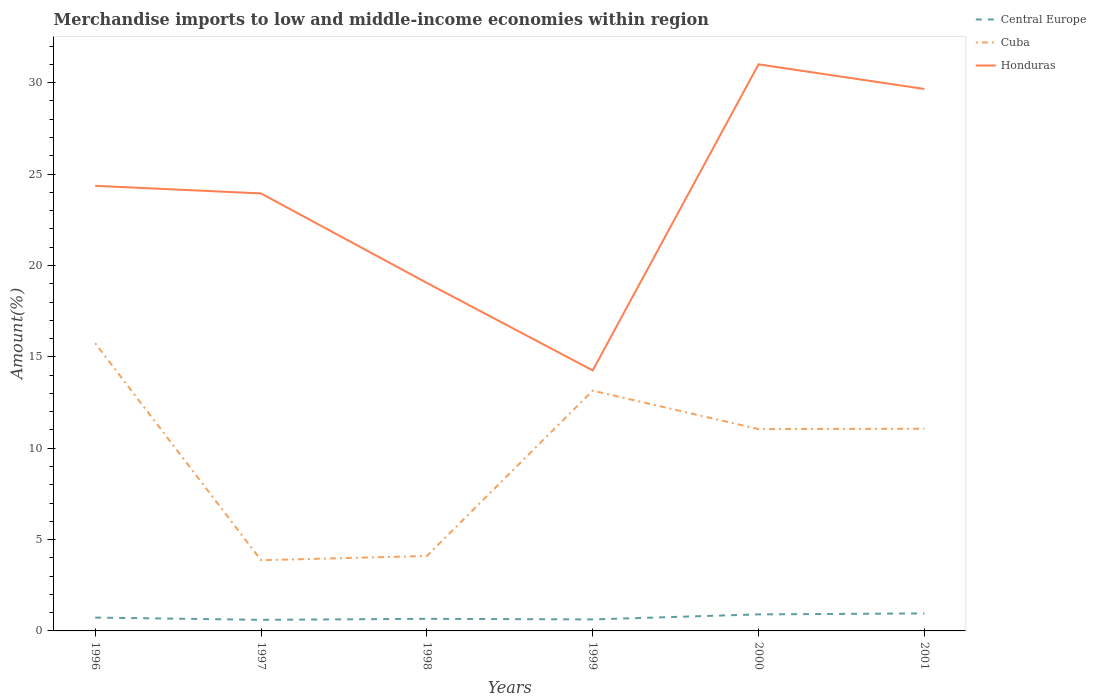How many different coloured lines are there?
Offer a terse response. 3. Across all years, what is the maximum percentage of amount earned from merchandise imports in Honduras?
Offer a very short reply. 14.26. In which year was the percentage of amount earned from merchandise imports in Honduras maximum?
Your response must be concise. 1999. What is the total percentage of amount earned from merchandise imports in Honduras in the graph?
Your answer should be compact. -5.3. What is the difference between the highest and the second highest percentage of amount earned from merchandise imports in Honduras?
Make the answer very short. 16.75. What is the difference between the highest and the lowest percentage of amount earned from merchandise imports in Central Europe?
Offer a very short reply. 2. Is the percentage of amount earned from merchandise imports in Cuba strictly greater than the percentage of amount earned from merchandise imports in Honduras over the years?
Keep it short and to the point. Yes. How many years are there in the graph?
Keep it short and to the point. 6. What is the difference between two consecutive major ticks on the Y-axis?
Your response must be concise. 5. Does the graph contain grids?
Make the answer very short. No. How are the legend labels stacked?
Offer a very short reply. Vertical. What is the title of the graph?
Offer a terse response. Merchandise imports to low and middle-income economies within region. Does "Namibia" appear as one of the legend labels in the graph?
Make the answer very short. No. What is the label or title of the X-axis?
Provide a short and direct response. Years. What is the label or title of the Y-axis?
Give a very brief answer. Amount(%). What is the Amount(%) in Central Europe in 1996?
Your answer should be very brief. 0.73. What is the Amount(%) of Cuba in 1996?
Give a very brief answer. 15.75. What is the Amount(%) in Honduras in 1996?
Provide a succinct answer. 24.36. What is the Amount(%) in Central Europe in 1997?
Make the answer very short. 0.61. What is the Amount(%) in Cuba in 1997?
Make the answer very short. 3.87. What is the Amount(%) of Honduras in 1997?
Provide a short and direct response. 23.94. What is the Amount(%) of Central Europe in 1998?
Offer a terse response. 0.66. What is the Amount(%) of Cuba in 1998?
Provide a short and direct response. 4.1. What is the Amount(%) in Honduras in 1998?
Provide a succinct answer. 19.05. What is the Amount(%) in Central Europe in 1999?
Your response must be concise. 0.63. What is the Amount(%) in Cuba in 1999?
Offer a terse response. 13.15. What is the Amount(%) in Honduras in 1999?
Provide a succinct answer. 14.26. What is the Amount(%) in Central Europe in 2000?
Your response must be concise. 0.91. What is the Amount(%) in Cuba in 2000?
Offer a terse response. 11.05. What is the Amount(%) in Honduras in 2000?
Keep it short and to the point. 31.01. What is the Amount(%) of Central Europe in 2001?
Make the answer very short. 0.96. What is the Amount(%) in Cuba in 2001?
Ensure brevity in your answer.  11.07. What is the Amount(%) in Honduras in 2001?
Offer a terse response. 29.66. Across all years, what is the maximum Amount(%) in Central Europe?
Provide a succinct answer. 0.96. Across all years, what is the maximum Amount(%) in Cuba?
Offer a very short reply. 15.75. Across all years, what is the maximum Amount(%) in Honduras?
Offer a terse response. 31.01. Across all years, what is the minimum Amount(%) in Central Europe?
Ensure brevity in your answer.  0.61. Across all years, what is the minimum Amount(%) of Cuba?
Your answer should be compact. 3.87. Across all years, what is the minimum Amount(%) of Honduras?
Keep it short and to the point. 14.26. What is the total Amount(%) in Central Europe in the graph?
Offer a terse response. 4.49. What is the total Amount(%) of Cuba in the graph?
Make the answer very short. 58.98. What is the total Amount(%) in Honduras in the graph?
Your response must be concise. 142.26. What is the difference between the Amount(%) in Central Europe in 1996 and that in 1997?
Give a very brief answer. 0.12. What is the difference between the Amount(%) in Cuba in 1996 and that in 1997?
Your answer should be compact. 11.88. What is the difference between the Amount(%) of Honduras in 1996 and that in 1997?
Provide a short and direct response. 0.42. What is the difference between the Amount(%) of Central Europe in 1996 and that in 1998?
Provide a succinct answer. 0.07. What is the difference between the Amount(%) of Cuba in 1996 and that in 1998?
Your answer should be compact. 11.65. What is the difference between the Amount(%) in Honduras in 1996 and that in 1998?
Your answer should be very brief. 5.31. What is the difference between the Amount(%) in Central Europe in 1996 and that in 1999?
Your response must be concise. 0.1. What is the difference between the Amount(%) of Cuba in 1996 and that in 1999?
Your answer should be compact. 2.6. What is the difference between the Amount(%) of Honduras in 1996 and that in 1999?
Your response must be concise. 10.1. What is the difference between the Amount(%) of Central Europe in 1996 and that in 2000?
Your answer should be compact. -0.17. What is the difference between the Amount(%) in Cuba in 1996 and that in 2000?
Your answer should be very brief. 4.7. What is the difference between the Amount(%) of Honduras in 1996 and that in 2000?
Offer a very short reply. -6.65. What is the difference between the Amount(%) of Central Europe in 1996 and that in 2001?
Offer a terse response. -0.23. What is the difference between the Amount(%) of Cuba in 1996 and that in 2001?
Give a very brief answer. 4.68. What is the difference between the Amount(%) of Honduras in 1996 and that in 2001?
Provide a short and direct response. -5.3. What is the difference between the Amount(%) of Central Europe in 1997 and that in 1998?
Offer a terse response. -0.05. What is the difference between the Amount(%) of Cuba in 1997 and that in 1998?
Offer a very short reply. -0.23. What is the difference between the Amount(%) in Honduras in 1997 and that in 1998?
Offer a terse response. 4.9. What is the difference between the Amount(%) in Central Europe in 1997 and that in 1999?
Your answer should be very brief. -0.02. What is the difference between the Amount(%) in Cuba in 1997 and that in 1999?
Your answer should be very brief. -9.28. What is the difference between the Amount(%) of Honduras in 1997 and that in 1999?
Your answer should be compact. 9.69. What is the difference between the Amount(%) in Central Europe in 1997 and that in 2000?
Ensure brevity in your answer.  -0.3. What is the difference between the Amount(%) in Cuba in 1997 and that in 2000?
Keep it short and to the point. -7.18. What is the difference between the Amount(%) of Honduras in 1997 and that in 2000?
Your answer should be compact. -7.06. What is the difference between the Amount(%) of Central Europe in 1997 and that in 2001?
Your answer should be very brief. -0.35. What is the difference between the Amount(%) of Cuba in 1997 and that in 2001?
Ensure brevity in your answer.  -7.2. What is the difference between the Amount(%) of Honduras in 1997 and that in 2001?
Offer a very short reply. -5.72. What is the difference between the Amount(%) in Central Europe in 1998 and that in 1999?
Your answer should be very brief. 0.03. What is the difference between the Amount(%) of Cuba in 1998 and that in 1999?
Make the answer very short. -9.05. What is the difference between the Amount(%) of Honduras in 1998 and that in 1999?
Offer a terse response. 4.79. What is the difference between the Amount(%) in Central Europe in 1998 and that in 2000?
Make the answer very short. -0.24. What is the difference between the Amount(%) in Cuba in 1998 and that in 2000?
Offer a very short reply. -6.94. What is the difference between the Amount(%) in Honduras in 1998 and that in 2000?
Provide a short and direct response. -11.96. What is the difference between the Amount(%) of Central Europe in 1998 and that in 2001?
Keep it short and to the point. -0.3. What is the difference between the Amount(%) of Cuba in 1998 and that in 2001?
Ensure brevity in your answer.  -6.97. What is the difference between the Amount(%) in Honduras in 1998 and that in 2001?
Provide a succinct answer. -10.61. What is the difference between the Amount(%) of Central Europe in 1999 and that in 2000?
Your response must be concise. -0.28. What is the difference between the Amount(%) of Cuba in 1999 and that in 2000?
Make the answer very short. 2.1. What is the difference between the Amount(%) in Honduras in 1999 and that in 2000?
Ensure brevity in your answer.  -16.75. What is the difference between the Amount(%) in Central Europe in 1999 and that in 2001?
Make the answer very short. -0.33. What is the difference between the Amount(%) in Cuba in 1999 and that in 2001?
Offer a terse response. 2.08. What is the difference between the Amount(%) in Honduras in 1999 and that in 2001?
Provide a succinct answer. -15.4. What is the difference between the Amount(%) of Central Europe in 2000 and that in 2001?
Your answer should be compact. -0.05. What is the difference between the Amount(%) of Cuba in 2000 and that in 2001?
Keep it short and to the point. -0.02. What is the difference between the Amount(%) in Honduras in 2000 and that in 2001?
Offer a very short reply. 1.35. What is the difference between the Amount(%) in Central Europe in 1996 and the Amount(%) in Cuba in 1997?
Provide a short and direct response. -3.14. What is the difference between the Amount(%) of Central Europe in 1996 and the Amount(%) of Honduras in 1997?
Provide a short and direct response. -23.21. What is the difference between the Amount(%) of Cuba in 1996 and the Amount(%) of Honduras in 1997?
Offer a very short reply. -8.19. What is the difference between the Amount(%) of Central Europe in 1996 and the Amount(%) of Cuba in 1998?
Offer a very short reply. -3.37. What is the difference between the Amount(%) of Central Europe in 1996 and the Amount(%) of Honduras in 1998?
Your answer should be compact. -18.32. What is the difference between the Amount(%) in Cuba in 1996 and the Amount(%) in Honduras in 1998?
Offer a terse response. -3.3. What is the difference between the Amount(%) in Central Europe in 1996 and the Amount(%) in Cuba in 1999?
Provide a succinct answer. -12.42. What is the difference between the Amount(%) in Central Europe in 1996 and the Amount(%) in Honduras in 1999?
Make the answer very short. -13.53. What is the difference between the Amount(%) of Cuba in 1996 and the Amount(%) of Honduras in 1999?
Provide a short and direct response. 1.49. What is the difference between the Amount(%) of Central Europe in 1996 and the Amount(%) of Cuba in 2000?
Keep it short and to the point. -10.31. What is the difference between the Amount(%) in Central Europe in 1996 and the Amount(%) in Honduras in 2000?
Your answer should be compact. -30.28. What is the difference between the Amount(%) of Cuba in 1996 and the Amount(%) of Honduras in 2000?
Your answer should be compact. -15.26. What is the difference between the Amount(%) in Central Europe in 1996 and the Amount(%) in Cuba in 2001?
Your answer should be very brief. -10.34. What is the difference between the Amount(%) in Central Europe in 1996 and the Amount(%) in Honduras in 2001?
Provide a short and direct response. -28.93. What is the difference between the Amount(%) in Cuba in 1996 and the Amount(%) in Honduras in 2001?
Give a very brief answer. -13.91. What is the difference between the Amount(%) of Central Europe in 1997 and the Amount(%) of Cuba in 1998?
Provide a succinct answer. -3.49. What is the difference between the Amount(%) in Central Europe in 1997 and the Amount(%) in Honduras in 1998?
Provide a short and direct response. -18.44. What is the difference between the Amount(%) of Cuba in 1997 and the Amount(%) of Honduras in 1998?
Offer a very short reply. -15.18. What is the difference between the Amount(%) in Central Europe in 1997 and the Amount(%) in Cuba in 1999?
Keep it short and to the point. -12.54. What is the difference between the Amount(%) in Central Europe in 1997 and the Amount(%) in Honduras in 1999?
Keep it short and to the point. -13.65. What is the difference between the Amount(%) of Cuba in 1997 and the Amount(%) of Honduras in 1999?
Give a very brief answer. -10.39. What is the difference between the Amount(%) in Central Europe in 1997 and the Amount(%) in Cuba in 2000?
Provide a short and direct response. -10.44. What is the difference between the Amount(%) in Central Europe in 1997 and the Amount(%) in Honduras in 2000?
Keep it short and to the point. -30.4. What is the difference between the Amount(%) in Cuba in 1997 and the Amount(%) in Honduras in 2000?
Offer a very short reply. -27.14. What is the difference between the Amount(%) of Central Europe in 1997 and the Amount(%) of Cuba in 2001?
Your answer should be compact. -10.46. What is the difference between the Amount(%) of Central Europe in 1997 and the Amount(%) of Honduras in 2001?
Make the answer very short. -29.05. What is the difference between the Amount(%) of Cuba in 1997 and the Amount(%) of Honduras in 2001?
Give a very brief answer. -25.79. What is the difference between the Amount(%) in Central Europe in 1998 and the Amount(%) in Cuba in 1999?
Provide a short and direct response. -12.49. What is the difference between the Amount(%) in Central Europe in 1998 and the Amount(%) in Honduras in 1999?
Ensure brevity in your answer.  -13.59. What is the difference between the Amount(%) of Cuba in 1998 and the Amount(%) of Honduras in 1999?
Offer a terse response. -10.15. What is the difference between the Amount(%) in Central Europe in 1998 and the Amount(%) in Cuba in 2000?
Give a very brief answer. -10.38. What is the difference between the Amount(%) of Central Europe in 1998 and the Amount(%) of Honduras in 2000?
Your answer should be very brief. -30.34. What is the difference between the Amount(%) in Cuba in 1998 and the Amount(%) in Honduras in 2000?
Your response must be concise. -26.9. What is the difference between the Amount(%) of Central Europe in 1998 and the Amount(%) of Cuba in 2001?
Provide a short and direct response. -10.4. What is the difference between the Amount(%) of Central Europe in 1998 and the Amount(%) of Honduras in 2001?
Give a very brief answer. -29. What is the difference between the Amount(%) in Cuba in 1998 and the Amount(%) in Honduras in 2001?
Offer a very short reply. -25.56. What is the difference between the Amount(%) in Central Europe in 1999 and the Amount(%) in Cuba in 2000?
Give a very brief answer. -10.42. What is the difference between the Amount(%) in Central Europe in 1999 and the Amount(%) in Honduras in 2000?
Make the answer very short. -30.38. What is the difference between the Amount(%) of Cuba in 1999 and the Amount(%) of Honduras in 2000?
Your response must be concise. -17.86. What is the difference between the Amount(%) of Central Europe in 1999 and the Amount(%) of Cuba in 2001?
Provide a short and direct response. -10.44. What is the difference between the Amount(%) in Central Europe in 1999 and the Amount(%) in Honduras in 2001?
Offer a terse response. -29.03. What is the difference between the Amount(%) in Cuba in 1999 and the Amount(%) in Honduras in 2001?
Make the answer very short. -16.51. What is the difference between the Amount(%) in Central Europe in 2000 and the Amount(%) in Cuba in 2001?
Your response must be concise. -10.16. What is the difference between the Amount(%) of Central Europe in 2000 and the Amount(%) of Honduras in 2001?
Make the answer very short. -28.75. What is the difference between the Amount(%) of Cuba in 2000 and the Amount(%) of Honduras in 2001?
Give a very brief answer. -18.61. What is the average Amount(%) in Central Europe per year?
Make the answer very short. 0.75. What is the average Amount(%) of Cuba per year?
Your answer should be very brief. 9.83. What is the average Amount(%) in Honduras per year?
Offer a very short reply. 23.71. In the year 1996, what is the difference between the Amount(%) of Central Europe and Amount(%) of Cuba?
Your answer should be very brief. -15.02. In the year 1996, what is the difference between the Amount(%) of Central Europe and Amount(%) of Honduras?
Give a very brief answer. -23.63. In the year 1996, what is the difference between the Amount(%) in Cuba and Amount(%) in Honduras?
Make the answer very short. -8.61. In the year 1997, what is the difference between the Amount(%) of Central Europe and Amount(%) of Cuba?
Provide a succinct answer. -3.26. In the year 1997, what is the difference between the Amount(%) in Central Europe and Amount(%) in Honduras?
Make the answer very short. -23.33. In the year 1997, what is the difference between the Amount(%) in Cuba and Amount(%) in Honduras?
Provide a short and direct response. -20.07. In the year 1998, what is the difference between the Amount(%) in Central Europe and Amount(%) in Cuba?
Keep it short and to the point. -3.44. In the year 1998, what is the difference between the Amount(%) of Central Europe and Amount(%) of Honduras?
Your answer should be compact. -18.38. In the year 1998, what is the difference between the Amount(%) in Cuba and Amount(%) in Honduras?
Your answer should be very brief. -14.94. In the year 1999, what is the difference between the Amount(%) in Central Europe and Amount(%) in Cuba?
Give a very brief answer. -12.52. In the year 1999, what is the difference between the Amount(%) of Central Europe and Amount(%) of Honduras?
Offer a terse response. -13.63. In the year 1999, what is the difference between the Amount(%) in Cuba and Amount(%) in Honduras?
Offer a terse response. -1.11. In the year 2000, what is the difference between the Amount(%) of Central Europe and Amount(%) of Cuba?
Make the answer very short. -10.14. In the year 2000, what is the difference between the Amount(%) in Central Europe and Amount(%) in Honduras?
Make the answer very short. -30.1. In the year 2000, what is the difference between the Amount(%) of Cuba and Amount(%) of Honduras?
Make the answer very short. -19.96. In the year 2001, what is the difference between the Amount(%) in Central Europe and Amount(%) in Cuba?
Your answer should be compact. -10.11. In the year 2001, what is the difference between the Amount(%) of Central Europe and Amount(%) of Honduras?
Your response must be concise. -28.7. In the year 2001, what is the difference between the Amount(%) in Cuba and Amount(%) in Honduras?
Make the answer very short. -18.59. What is the ratio of the Amount(%) of Central Europe in 1996 to that in 1997?
Offer a very short reply. 1.2. What is the ratio of the Amount(%) of Cuba in 1996 to that in 1997?
Provide a short and direct response. 4.07. What is the ratio of the Amount(%) in Honduras in 1996 to that in 1997?
Offer a terse response. 1.02. What is the ratio of the Amount(%) in Central Europe in 1996 to that in 1998?
Make the answer very short. 1.1. What is the ratio of the Amount(%) in Cuba in 1996 to that in 1998?
Your answer should be compact. 3.84. What is the ratio of the Amount(%) in Honduras in 1996 to that in 1998?
Provide a short and direct response. 1.28. What is the ratio of the Amount(%) of Central Europe in 1996 to that in 1999?
Your response must be concise. 1.16. What is the ratio of the Amount(%) of Cuba in 1996 to that in 1999?
Ensure brevity in your answer.  1.2. What is the ratio of the Amount(%) in Honduras in 1996 to that in 1999?
Offer a terse response. 1.71. What is the ratio of the Amount(%) in Central Europe in 1996 to that in 2000?
Offer a terse response. 0.81. What is the ratio of the Amount(%) of Cuba in 1996 to that in 2000?
Provide a short and direct response. 1.43. What is the ratio of the Amount(%) in Honduras in 1996 to that in 2000?
Provide a short and direct response. 0.79. What is the ratio of the Amount(%) of Central Europe in 1996 to that in 2001?
Keep it short and to the point. 0.76. What is the ratio of the Amount(%) of Cuba in 1996 to that in 2001?
Provide a short and direct response. 1.42. What is the ratio of the Amount(%) of Honduras in 1996 to that in 2001?
Ensure brevity in your answer.  0.82. What is the ratio of the Amount(%) of Central Europe in 1997 to that in 1998?
Your response must be concise. 0.92. What is the ratio of the Amount(%) in Cuba in 1997 to that in 1998?
Your response must be concise. 0.94. What is the ratio of the Amount(%) of Honduras in 1997 to that in 1998?
Offer a terse response. 1.26. What is the ratio of the Amount(%) of Central Europe in 1997 to that in 1999?
Ensure brevity in your answer.  0.97. What is the ratio of the Amount(%) in Cuba in 1997 to that in 1999?
Offer a terse response. 0.29. What is the ratio of the Amount(%) in Honduras in 1997 to that in 1999?
Make the answer very short. 1.68. What is the ratio of the Amount(%) in Central Europe in 1997 to that in 2000?
Offer a very short reply. 0.67. What is the ratio of the Amount(%) of Cuba in 1997 to that in 2000?
Offer a very short reply. 0.35. What is the ratio of the Amount(%) in Honduras in 1997 to that in 2000?
Make the answer very short. 0.77. What is the ratio of the Amount(%) of Central Europe in 1997 to that in 2001?
Provide a short and direct response. 0.63. What is the ratio of the Amount(%) of Cuba in 1997 to that in 2001?
Provide a short and direct response. 0.35. What is the ratio of the Amount(%) of Honduras in 1997 to that in 2001?
Offer a terse response. 0.81. What is the ratio of the Amount(%) in Central Europe in 1998 to that in 1999?
Make the answer very short. 1.05. What is the ratio of the Amount(%) in Cuba in 1998 to that in 1999?
Give a very brief answer. 0.31. What is the ratio of the Amount(%) in Honduras in 1998 to that in 1999?
Offer a terse response. 1.34. What is the ratio of the Amount(%) in Central Europe in 1998 to that in 2000?
Give a very brief answer. 0.73. What is the ratio of the Amount(%) in Cuba in 1998 to that in 2000?
Your answer should be very brief. 0.37. What is the ratio of the Amount(%) of Honduras in 1998 to that in 2000?
Your answer should be compact. 0.61. What is the ratio of the Amount(%) in Central Europe in 1998 to that in 2001?
Give a very brief answer. 0.69. What is the ratio of the Amount(%) in Cuba in 1998 to that in 2001?
Offer a terse response. 0.37. What is the ratio of the Amount(%) of Honduras in 1998 to that in 2001?
Give a very brief answer. 0.64. What is the ratio of the Amount(%) in Central Europe in 1999 to that in 2000?
Your answer should be very brief. 0.69. What is the ratio of the Amount(%) in Cuba in 1999 to that in 2000?
Ensure brevity in your answer.  1.19. What is the ratio of the Amount(%) of Honduras in 1999 to that in 2000?
Your response must be concise. 0.46. What is the ratio of the Amount(%) in Central Europe in 1999 to that in 2001?
Your answer should be compact. 0.66. What is the ratio of the Amount(%) of Cuba in 1999 to that in 2001?
Keep it short and to the point. 1.19. What is the ratio of the Amount(%) of Honduras in 1999 to that in 2001?
Keep it short and to the point. 0.48. What is the ratio of the Amount(%) in Central Europe in 2000 to that in 2001?
Your answer should be very brief. 0.94. What is the ratio of the Amount(%) in Honduras in 2000 to that in 2001?
Provide a short and direct response. 1.05. What is the difference between the highest and the second highest Amount(%) of Central Europe?
Your answer should be compact. 0.05. What is the difference between the highest and the second highest Amount(%) of Cuba?
Your answer should be compact. 2.6. What is the difference between the highest and the second highest Amount(%) in Honduras?
Offer a very short reply. 1.35. What is the difference between the highest and the lowest Amount(%) in Central Europe?
Make the answer very short. 0.35. What is the difference between the highest and the lowest Amount(%) of Cuba?
Your answer should be very brief. 11.88. What is the difference between the highest and the lowest Amount(%) of Honduras?
Ensure brevity in your answer.  16.75. 